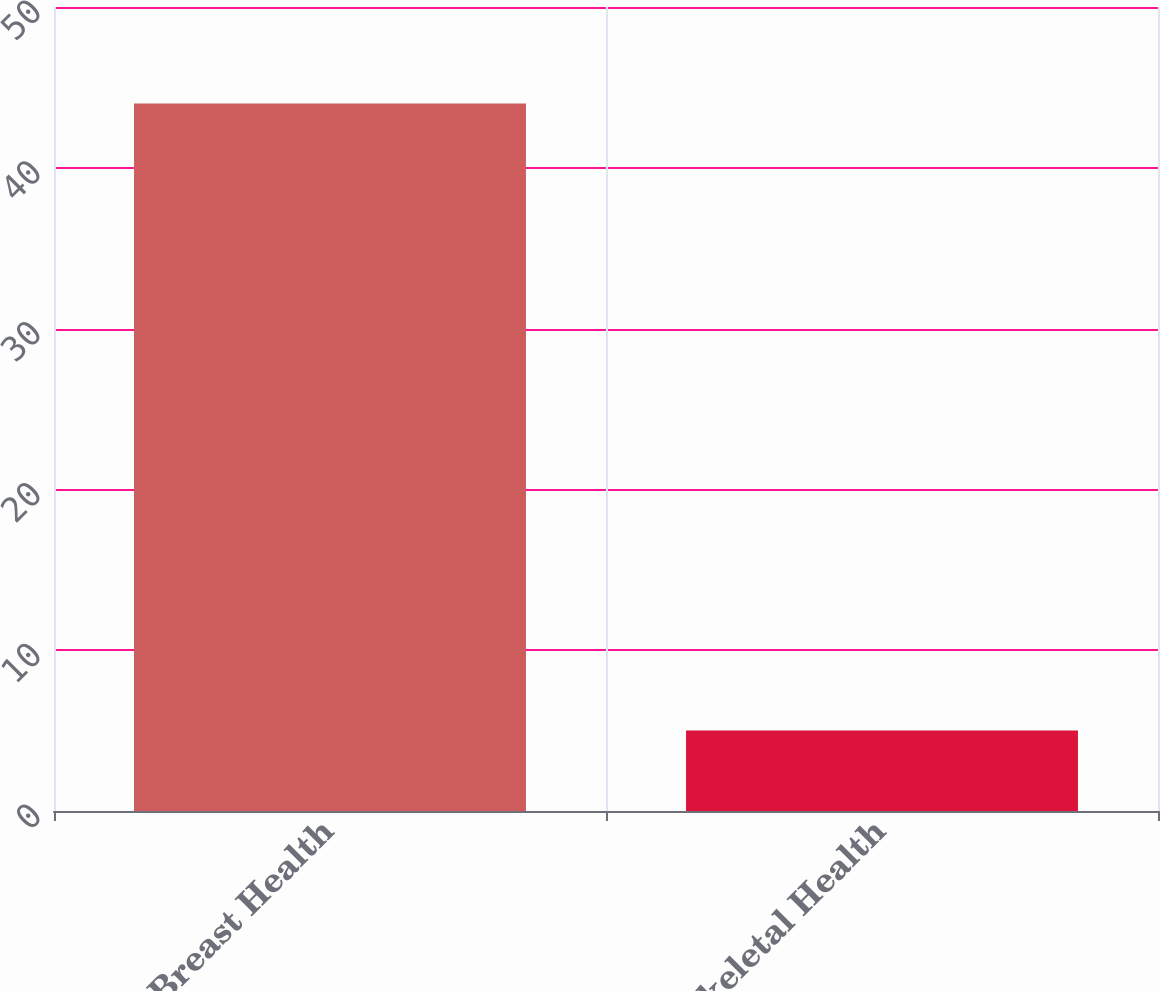Convert chart to OTSL. <chart><loc_0><loc_0><loc_500><loc_500><bar_chart><fcel>Breast Health<fcel>Skeletal Health<nl><fcel>44<fcel>5<nl></chart> 